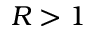Convert formula to latex. <formula><loc_0><loc_0><loc_500><loc_500>R > 1</formula> 